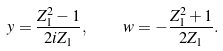<formula> <loc_0><loc_0><loc_500><loc_500>y = \frac { Z _ { 1 } ^ { 2 } - 1 } { 2 i Z _ { 1 } } , \quad w = - \frac { Z _ { 1 } ^ { 2 } + 1 } { 2 Z _ { 1 } } .</formula> 